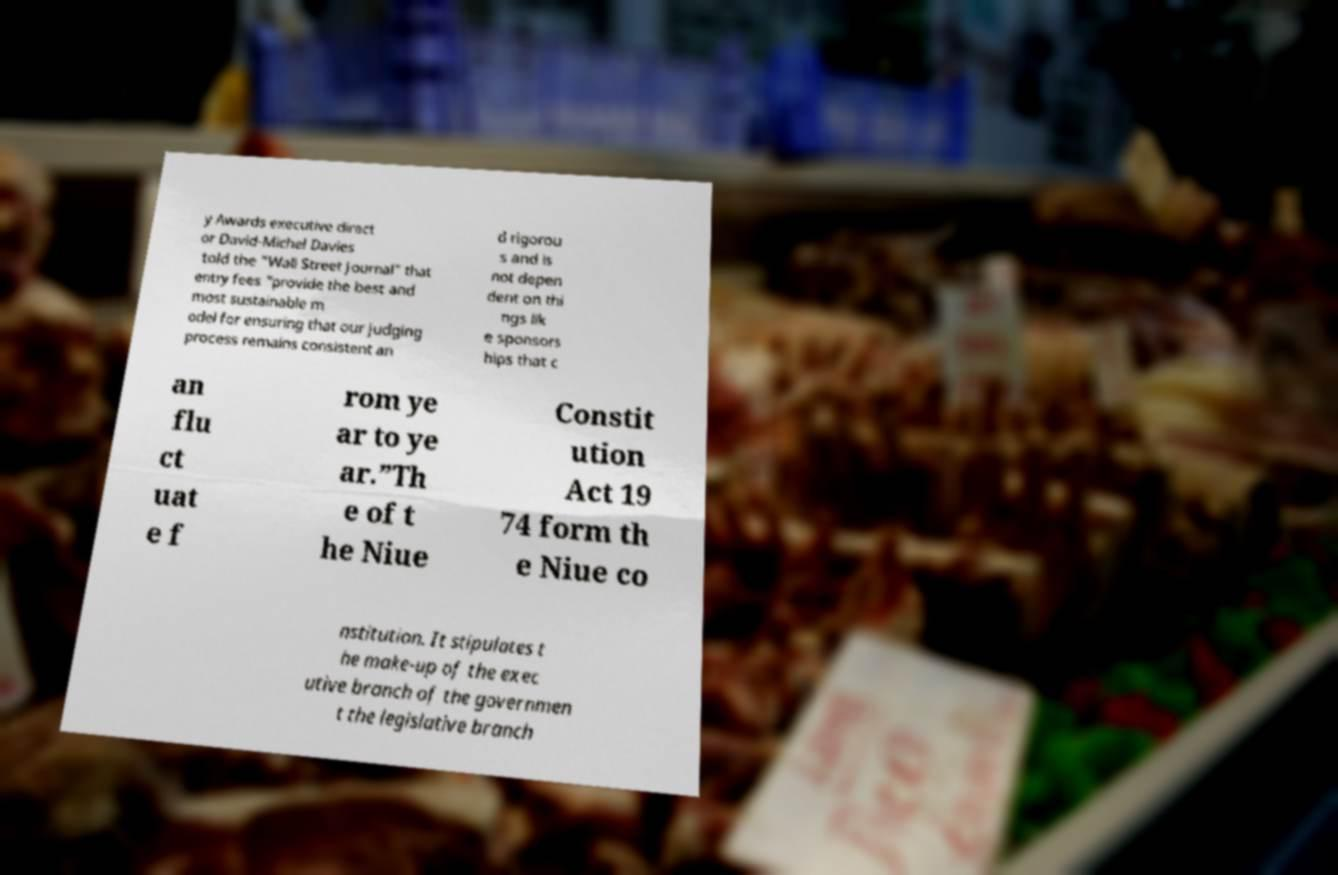Please identify and transcribe the text found in this image. y Awards executive direct or David-Michel Davies told the "Wall Street Journal" that entry fees “provide the best and most sustainable m odel for ensuring that our judging process remains consistent an d rigorou s and is not depen dent on thi ngs lik e sponsors hips that c an flu ct uat e f rom ye ar to ye ar.”Th e of t he Niue Constit ution Act 19 74 form th e Niue co nstitution. It stipulates t he make-up of the exec utive branch of the governmen t the legislative branch 